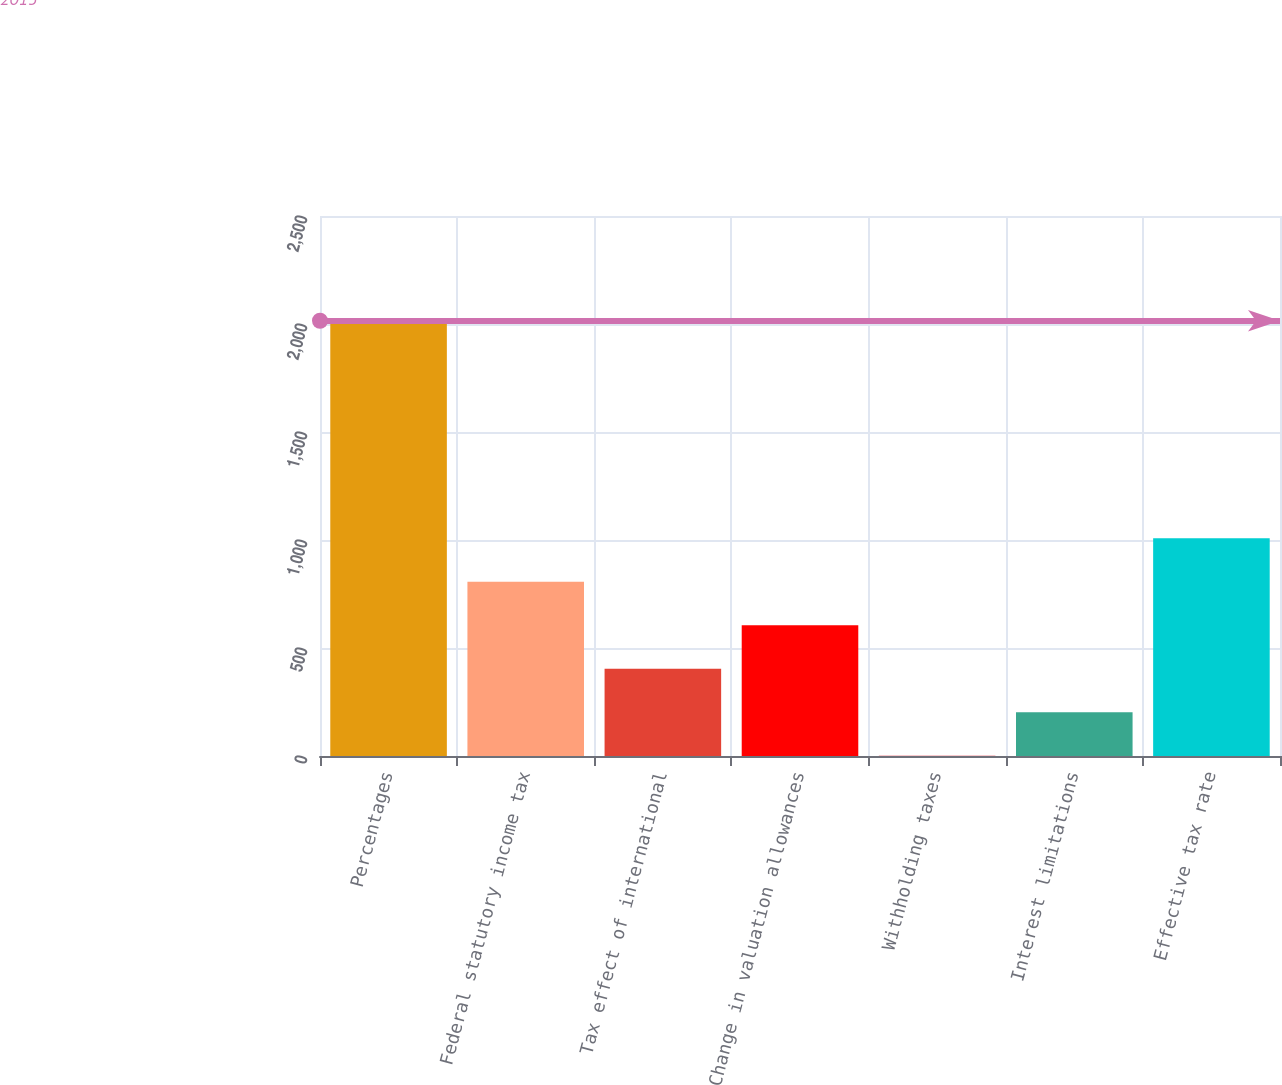Convert chart to OTSL. <chart><loc_0><loc_0><loc_500><loc_500><bar_chart><fcel>Percentages<fcel>Federal statutory income tax<fcel>Tax effect of international<fcel>Change in valuation allowances<fcel>Withholding taxes<fcel>Interest limitations<fcel>Effective tax rate<nl><fcel>2015<fcel>806.36<fcel>403.48<fcel>604.92<fcel>0.6<fcel>202.04<fcel>1007.8<nl></chart> 